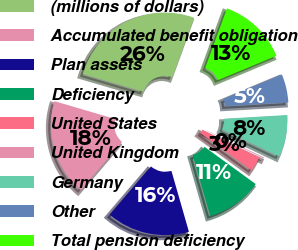Convert chart to OTSL. <chart><loc_0><loc_0><loc_500><loc_500><pie_chart><fcel>(millions of dollars)<fcel>Accumulated benefit obligation<fcel>Plan assets<fcel>Deficiency<fcel>United States<fcel>United Kingdom<fcel>Germany<fcel>Other<fcel>Total pension deficiency<nl><fcel>26.04%<fcel>18.29%<fcel>15.71%<fcel>10.54%<fcel>2.78%<fcel>0.2%<fcel>7.95%<fcel>5.37%<fcel>13.12%<nl></chart> 